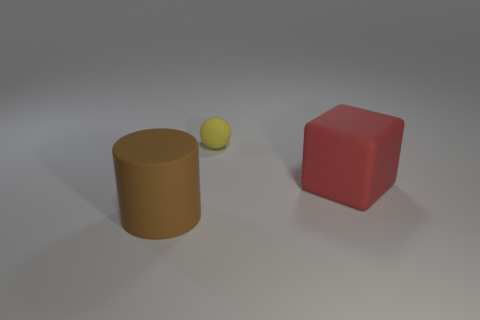There is a object in front of the big thing that is behind the big matte object that is in front of the large red cube; how big is it?
Your answer should be very brief. Large. Are there more rubber cylinders than small yellow cylinders?
Provide a short and direct response. Yes. Is the color of the rubber object that is behind the large matte block the same as the object on the left side of the yellow matte ball?
Ensure brevity in your answer.  No. Do the large thing in front of the rubber cube and the thing that is behind the block have the same material?
Your response must be concise. Yes. How many balls have the same size as the red block?
Your response must be concise. 0. Are there fewer tiny purple matte cylinders than yellow things?
Ensure brevity in your answer.  Yes. What shape is the big rubber object that is in front of the large thing that is on the right side of the large cylinder?
Keep it short and to the point. Cylinder. The red object that is the same size as the brown cylinder is what shape?
Ensure brevity in your answer.  Cube. Is there a small yellow object that has the same shape as the brown rubber object?
Offer a very short reply. No. What is the material of the big brown cylinder?
Your response must be concise. Rubber. 